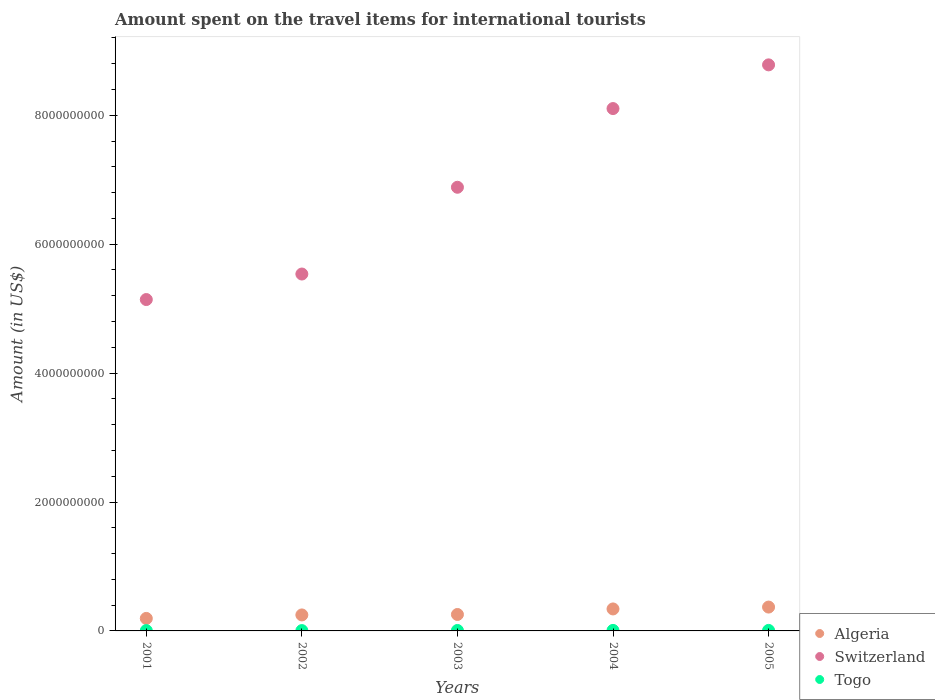Is the number of dotlines equal to the number of legend labels?
Give a very brief answer. Yes. What is the amount spent on the travel items for international tourists in Algeria in 2001?
Your answer should be very brief. 1.94e+08. Across all years, what is the maximum amount spent on the travel items for international tourists in Togo?
Your response must be concise. 8.00e+06. Across all years, what is the minimum amount spent on the travel items for international tourists in Algeria?
Offer a terse response. 1.94e+08. In which year was the amount spent on the travel items for international tourists in Switzerland maximum?
Make the answer very short. 2005. In which year was the amount spent on the travel items for international tourists in Togo minimum?
Provide a short and direct response. 2001. What is the total amount spent on the travel items for international tourists in Switzerland in the graph?
Give a very brief answer. 3.44e+1. What is the difference between the amount spent on the travel items for international tourists in Togo in 2002 and that in 2003?
Offer a very short reply. -2.00e+06. What is the difference between the amount spent on the travel items for international tourists in Algeria in 2003 and the amount spent on the travel items for international tourists in Switzerland in 2001?
Make the answer very short. -4.89e+09. What is the average amount spent on the travel items for international tourists in Algeria per year?
Provide a short and direct response. 2.82e+08. In the year 2001, what is the difference between the amount spent on the travel items for international tourists in Switzerland and amount spent on the travel items for international tourists in Togo?
Provide a short and direct response. 5.14e+09. What is the ratio of the amount spent on the travel items for international tourists in Switzerland in 2001 to that in 2002?
Offer a terse response. 0.93. Is the difference between the amount spent on the travel items for international tourists in Switzerland in 2001 and 2003 greater than the difference between the amount spent on the travel items for international tourists in Togo in 2001 and 2003?
Your answer should be very brief. No. What is the difference between the highest and the second highest amount spent on the travel items for international tourists in Switzerland?
Your answer should be very brief. 6.78e+08. What is the difference between the highest and the lowest amount spent on the travel items for international tourists in Togo?
Make the answer very short. 3.00e+06. In how many years, is the amount spent on the travel items for international tourists in Algeria greater than the average amount spent on the travel items for international tourists in Algeria taken over all years?
Ensure brevity in your answer.  2. Does the amount spent on the travel items for international tourists in Togo monotonically increase over the years?
Provide a short and direct response. No. How many dotlines are there?
Ensure brevity in your answer.  3. Are the values on the major ticks of Y-axis written in scientific E-notation?
Your response must be concise. No. Where does the legend appear in the graph?
Keep it short and to the point. Bottom right. How are the legend labels stacked?
Keep it short and to the point. Vertical. What is the title of the graph?
Give a very brief answer. Amount spent on the travel items for international tourists. What is the label or title of the Y-axis?
Your answer should be compact. Amount (in US$). What is the Amount (in US$) of Algeria in 2001?
Offer a very short reply. 1.94e+08. What is the Amount (in US$) in Switzerland in 2001?
Ensure brevity in your answer.  5.14e+09. What is the Amount (in US$) of Algeria in 2002?
Provide a succinct answer. 2.48e+08. What is the Amount (in US$) in Switzerland in 2002?
Provide a succinct answer. 5.54e+09. What is the Amount (in US$) in Togo in 2002?
Provide a succinct answer. 5.00e+06. What is the Amount (in US$) in Algeria in 2003?
Your answer should be very brief. 2.55e+08. What is the Amount (in US$) in Switzerland in 2003?
Offer a terse response. 6.88e+09. What is the Amount (in US$) in Togo in 2003?
Provide a succinct answer. 7.00e+06. What is the Amount (in US$) in Algeria in 2004?
Provide a succinct answer. 3.41e+08. What is the Amount (in US$) in Switzerland in 2004?
Your response must be concise. 8.10e+09. What is the Amount (in US$) of Algeria in 2005?
Your answer should be compact. 3.70e+08. What is the Amount (in US$) of Switzerland in 2005?
Give a very brief answer. 8.78e+09. Across all years, what is the maximum Amount (in US$) in Algeria?
Your answer should be compact. 3.70e+08. Across all years, what is the maximum Amount (in US$) of Switzerland?
Ensure brevity in your answer.  8.78e+09. Across all years, what is the maximum Amount (in US$) of Togo?
Make the answer very short. 8.00e+06. Across all years, what is the minimum Amount (in US$) in Algeria?
Provide a succinct answer. 1.94e+08. Across all years, what is the minimum Amount (in US$) in Switzerland?
Your response must be concise. 5.14e+09. Across all years, what is the minimum Amount (in US$) of Togo?
Provide a short and direct response. 5.00e+06. What is the total Amount (in US$) in Algeria in the graph?
Provide a succinct answer. 1.41e+09. What is the total Amount (in US$) of Switzerland in the graph?
Make the answer very short. 3.44e+1. What is the total Amount (in US$) in Togo in the graph?
Offer a very short reply. 3.30e+07. What is the difference between the Amount (in US$) in Algeria in 2001 and that in 2002?
Offer a terse response. -5.40e+07. What is the difference between the Amount (in US$) in Switzerland in 2001 and that in 2002?
Your response must be concise. -3.96e+08. What is the difference between the Amount (in US$) in Algeria in 2001 and that in 2003?
Your answer should be very brief. -6.10e+07. What is the difference between the Amount (in US$) of Switzerland in 2001 and that in 2003?
Make the answer very short. -1.74e+09. What is the difference between the Amount (in US$) of Togo in 2001 and that in 2003?
Provide a short and direct response. -2.00e+06. What is the difference between the Amount (in US$) in Algeria in 2001 and that in 2004?
Your answer should be compact. -1.47e+08. What is the difference between the Amount (in US$) in Switzerland in 2001 and that in 2004?
Provide a short and direct response. -2.96e+09. What is the difference between the Amount (in US$) in Algeria in 2001 and that in 2005?
Your answer should be compact. -1.76e+08. What is the difference between the Amount (in US$) of Switzerland in 2001 and that in 2005?
Offer a terse response. -3.64e+09. What is the difference between the Amount (in US$) of Algeria in 2002 and that in 2003?
Offer a very short reply. -7.00e+06. What is the difference between the Amount (in US$) in Switzerland in 2002 and that in 2003?
Offer a terse response. -1.35e+09. What is the difference between the Amount (in US$) in Togo in 2002 and that in 2003?
Your answer should be very brief. -2.00e+06. What is the difference between the Amount (in US$) in Algeria in 2002 and that in 2004?
Offer a terse response. -9.30e+07. What is the difference between the Amount (in US$) in Switzerland in 2002 and that in 2004?
Make the answer very short. -2.57e+09. What is the difference between the Amount (in US$) in Algeria in 2002 and that in 2005?
Offer a terse response. -1.22e+08. What is the difference between the Amount (in US$) in Switzerland in 2002 and that in 2005?
Provide a short and direct response. -3.24e+09. What is the difference between the Amount (in US$) of Togo in 2002 and that in 2005?
Keep it short and to the point. -3.00e+06. What is the difference between the Amount (in US$) of Algeria in 2003 and that in 2004?
Your response must be concise. -8.60e+07. What is the difference between the Amount (in US$) of Switzerland in 2003 and that in 2004?
Keep it short and to the point. -1.22e+09. What is the difference between the Amount (in US$) in Algeria in 2003 and that in 2005?
Offer a very short reply. -1.15e+08. What is the difference between the Amount (in US$) of Switzerland in 2003 and that in 2005?
Provide a short and direct response. -1.90e+09. What is the difference between the Amount (in US$) in Togo in 2003 and that in 2005?
Offer a very short reply. -1.00e+06. What is the difference between the Amount (in US$) of Algeria in 2004 and that in 2005?
Provide a succinct answer. -2.90e+07. What is the difference between the Amount (in US$) of Switzerland in 2004 and that in 2005?
Give a very brief answer. -6.78e+08. What is the difference between the Amount (in US$) of Togo in 2004 and that in 2005?
Provide a succinct answer. 0. What is the difference between the Amount (in US$) in Algeria in 2001 and the Amount (in US$) in Switzerland in 2002?
Offer a terse response. -5.34e+09. What is the difference between the Amount (in US$) in Algeria in 2001 and the Amount (in US$) in Togo in 2002?
Ensure brevity in your answer.  1.89e+08. What is the difference between the Amount (in US$) of Switzerland in 2001 and the Amount (in US$) of Togo in 2002?
Your answer should be compact. 5.14e+09. What is the difference between the Amount (in US$) in Algeria in 2001 and the Amount (in US$) in Switzerland in 2003?
Ensure brevity in your answer.  -6.69e+09. What is the difference between the Amount (in US$) of Algeria in 2001 and the Amount (in US$) of Togo in 2003?
Your answer should be very brief. 1.87e+08. What is the difference between the Amount (in US$) of Switzerland in 2001 and the Amount (in US$) of Togo in 2003?
Provide a short and direct response. 5.13e+09. What is the difference between the Amount (in US$) of Algeria in 2001 and the Amount (in US$) of Switzerland in 2004?
Offer a very short reply. -7.91e+09. What is the difference between the Amount (in US$) of Algeria in 2001 and the Amount (in US$) of Togo in 2004?
Ensure brevity in your answer.  1.86e+08. What is the difference between the Amount (in US$) of Switzerland in 2001 and the Amount (in US$) of Togo in 2004?
Your response must be concise. 5.13e+09. What is the difference between the Amount (in US$) in Algeria in 2001 and the Amount (in US$) in Switzerland in 2005?
Offer a very short reply. -8.59e+09. What is the difference between the Amount (in US$) in Algeria in 2001 and the Amount (in US$) in Togo in 2005?
Offer a very short reply. 1.86e+08. What is the difference between the Amount (in US$) in Switzerland in 2001 and the Amount (in US$) in Togo in 2005?
Offer a terse response. 5.13e+09. What is the difference between the Amount (in US$) of Algeria in 2002 and the Amount (in US$) of Switzerland in 2003?
Provide a short and direct response. -6.64e+09. What is the difference between the Amount (in US$) in Algeria in 2002 and the Amount (in US$) in Togo in 2003?
Provide a short and direct response. 2.41e+08. What is the difference between the Amount (in US$) in Switzerland in 2002 and the Amount (in US$) in Togo in 2003?
Offer a terse response. 5.53e+09. What is the difference between the Amount (in US$) in Algeria in 2002 and the Amount (in US$) in Switzerland in 2004?
Your answer should be compact. -7.86e+09. What is the difference between the Amount (in US$) in Algeria in 2002 and the Amount (in US$) in Togo in 2004?
Your response must be concise. 2.40e+08. What is the difference between the Amount (in US$) of Switzerland in 2002 and the Amount (in US$) of Togo in 2004?
Your answer should be very brief. 5.53e+09. What is the difference between the Amount (in US$) in Algeria in 2002 and the Amount (in US$) in Switzerland in 2005?
Provide a short and direct response. -8.53e+09. What is the difference between the Amount (in US$) of Algeria in 2002 and the Amount (in US$) of Togo in 2005?
Provide a succinct answer. 2.40e+08. What is the difference between the Amount (in US$) in Switzerland in 2002 and the Amount (in US$) in Togo in 2005?
Your response must be concise. 5.53e+09. What is the difference between the Amount (in US$) in Algeria in 2003 and the Amount (in US$) in Switzerland in 2004?
Ensure brevity in your answer.  -7.85e+09. What is the difference between the Amount (in US$) in Algeria in 2003 and the Amount (in US$) in Togo in 2004?
Your answer should be very brief. 2.47e+08. What is the difference between the Amount (in US$) in Switzerland in 2003 and the Amount (in US$) in Togo in 2004?
Give a very brief answer. 6.88e+09. What is the difference between the Amount (in US$) of Algeria in 2003 and the Amount (in US$) of Switzerland in 2005?
Ensure brevity in your answer.  -8.53e+09. What is the difference between the Amount (in US$) in Algeria in 2003 and the Amount (in US$) in Togo in 2005?
Your answer should be very brief. 2.47e+08. What is the difference between the Amount (in US$) of Switzerland in 2003 and the Amount (in US$) of Togo in 2005?
Your answer should be very brief. 6.88e+09. What is the difference between the Amount (in US$) of Algeria in 2004 and the Amount (in US$) of Switzerland in 2005?
Provide a short and direct response. -8.44e+09. What is the difference between the Amount (in US$) in Algeria in 2004 and the Amount (in US$) in Togo in 2005?
Give a very brief answer. 3.33e+08. What is the difference between the Amount (in US$) in Switzerland in 2004 and the Amount (in US$) in Togo in 2005?
Your answer should be very brief. 8.10e+09. What is the average Amount (in US$) of Algeria per year?
Keep it short and to the point. 2.82e+08. What is the average Amount (in US$) of Switzerland per year?
Your answer should be very brief. 6.89e+09. What is the average Amount (in US$) of Togo per year?
Offer a terse response. 6.60e+06. In the year 2001, what is the difference between the Amount (in US$) in Algeria and Amount (in US$) in Switzerland?
Your response must be concise. -4.95e+09. In the year 2001, what is the difference between the Amount (in US$) in Algeria and Amount (in US$) in Togo?
Your answer should be very brief. 1.89e+08. In the year 2001, what is the difference between the Amount (in US$) of Switzerland and Amount (in US$) of Togo?
Your answer should be compact. 5.14e+09. In the year 2002, what is the difference between the Amount (in US$) of Algeria and Amount (in US$) of Switzerland?
Offer a terse response. -5.29e+09. In the year 2002, what is the difference between the Amount (in US$) in Algeria and Amount (in US$) in Togo?
Offer a terse response. 2.43e+08. In the year 2002, what is the difference between the Amount (in US$) in Switzerland and Amount (in US$) in Togo?
Your answer should be compact. 5.53e+09. In the year 2003, what is the difference between the Amount (in US$) in Algeria and Amount (in US$) in Switzerland?
Offer a terse response. -6.63e+09. In the year 2003, what is the difference between the Amount (in US$) of Algeria and Amount (in US$) of Togo?
Offer a very short reply. 2.48e+08. In the year 2003, what is the difference between the Amount (in US$) of Switzerland and Amount (in US$) of Togo?
Give a very brief answer. 6.88e+09. In the year 2004, what is the difference between the Amount (in US$) of Algeria and Amount (in US$) of Switzerland?
Provide a short and direct response. -7.76e+09. In the year 2004, what is the difference between the Amount (in US$) of Algeria and Amount (in US$) of Togo?
Keep it short and to the point. 3.33e+08. In the year 2004, what is the difference between the Amount (in US$) in Switzerland and Amount (in US$) in Togo?
Your answer should be very brief. 8.10e+09. In the year 2005, what is the difference between the Amount (in US$) in Algeria and Amount (in US$) in Switzerland?
Ensure brevity in your answer.  -8.41e+09. In the year 2005, what is the difference between the Amount (in US$) in Algeria and Amount (in US$) in Togo?
Your response must be concise. 3.62e+08. In the year 2005, what is the difference between the Amount (in US$) in Switzerland and Amount (in US$) in Togo?
Your response must be concise. 8.77e+09. What is the ratio of the Amount (in US$) in Algeria in 2001 to that in 2002?
Your answer should be very brief. 0.78. What is the ratio of the Amount (in US$) in Switzerland in 2001 to that in 2002?
Provide a succinct answer. 0.93. What is the ratio of the Amount (in US$) in Togo in 2001 to that in 2002?
Offer a terse response. 1. What is the ratio of the Amount (in US$) in Algeria in 2001 to that in 2003?
Your answer should be compact. 0.76. What is the ratio of the Amount (in US$) of Switzerland in 2001 to that in 2003?
Make the answer very short. 0.75. What is the ratio of the Amount (in US$) of Algeria in 2001 to that in 2004?
Provide a succinct answer. 0.57. What is the ratio of the Amount (in US$) of Switzerland in 2001 to that in 2004?
Give a very brief answer. 0.63. What is the ratio of the Amount (in US$) of Algeria in 2001 to that in 2005?
Offer a very short reply. 0.52. What is the ratio of the Amount (in US$) in Switzerland in 2001 to that in 2005?
Your response must be concise. 0.59. What is the ratio of the Amount (in US$) in Togo in 2001 to that in 2005?
Ensure brevity in your answer.  0.62. What is the ratio of the Amount (in US$) of Algeria in 2002 to that in 2003?
Give a very brief answer. 0.97. What is the ratio of the Amount (in US$) in Switzerland in 2002 to that in 2003?
Offer a very short reply. 0.8. What is the ratio of the Amount (in US$) in Algeria in 2002 to that in 2004?
Offer a very short reply. 0.73. What is the ratio of the Amount (in US$) of Switzerland in 2002 to that in 2004?
Keep it short and to the point. 0.68. What is the ratio of the Amount (in US$) of Algeria in 2002 to that in 2005?
Ensure brevity in your answer.  0.67. What is the ratio of the Amount (in US$) of Switzerland in 2002 to that in 2005?
Provide a short and direct response. 0.63. What is the ratio of the Amount (in US$) in Algeria in 2003 to that in 2004?
Give a very brief answer. 0.75. What is the ratio of the Amount (in US$) of Switzerland in 2003 to that in 2004?
Your answer should be very brief. 0.85. What is the ratio of the Amount (in US$) in Togo in 2003 to that in 2004?
Make the answer very short. 0.88. What is the ratio of the Amount (in US$) in Algeria in 2003 to that in 2005?
Offer a very short reply. 0.69. What is the ratio of the Amount (in US$) of Switzerland in 2003 to that in 2005?
Provide a short and direct response. 0.78. What is the ratio of the Amount (in US$) of Algeria in 2004 to that in 2005?
Ensure brevity in your answer.  0.92. What is the ratio of the Amount (in US$) of Switzerland in 2004 to that in 2005?
Give a very brief answer. 0.92. What is the ratio of the Amount (in US$) of Togo in 2004 to that in 2005?
Your answer should be very brief. 1. What is the difference between the highest and the second highest Amount (in US$) in Algeria?
Keep it short and to the point. 2.90e+07. What is the difference between the highest and the second highest Amount (in US$) of Switzerland?
Provide a short and direct response. 6.78e+08. What is the difference between the highest and the lowest Amount (in US$) in Algeria?
Your response must be concise. 1.76e+08. What is the difference between the highest and the lowest Amount (in US$) of Switzerland?
Offer a very short reply. 3.64e+09. What is the difference between the highest and the lowest Amount (in US$) in Togo?
Keep it short and to the point. 3.00e+06. 